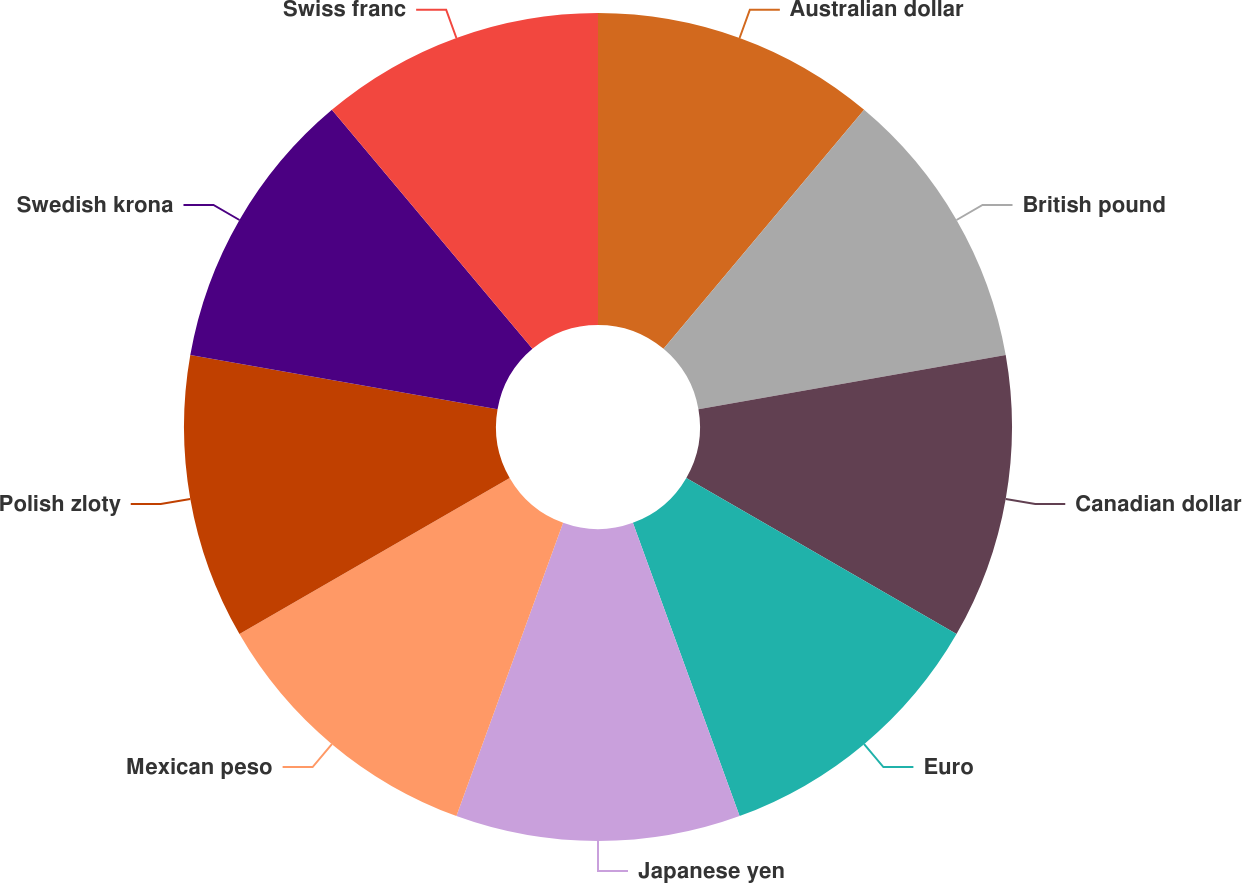Convert chart to OTSL. <chart><loc_0><loc_0><loc_500><loc_500><pie_chart><fcel>Australian dollar<fcel>British pound<fcel>Canadian dollar<fcel>Euro<fcel>Japanese yen<fcel>Mexican peso<fcel>Polish zloty<fcel>Swedish krona<fcel>Swiss franc<nl><fcel>11.11%<fcel>11.11%<fcel>11.11%<fcel>11.11%<fcel>11.11%<fcel>11.11%<fcel>11.11%<fcel>11.11%<fcel>11.11%<nl></chart> 